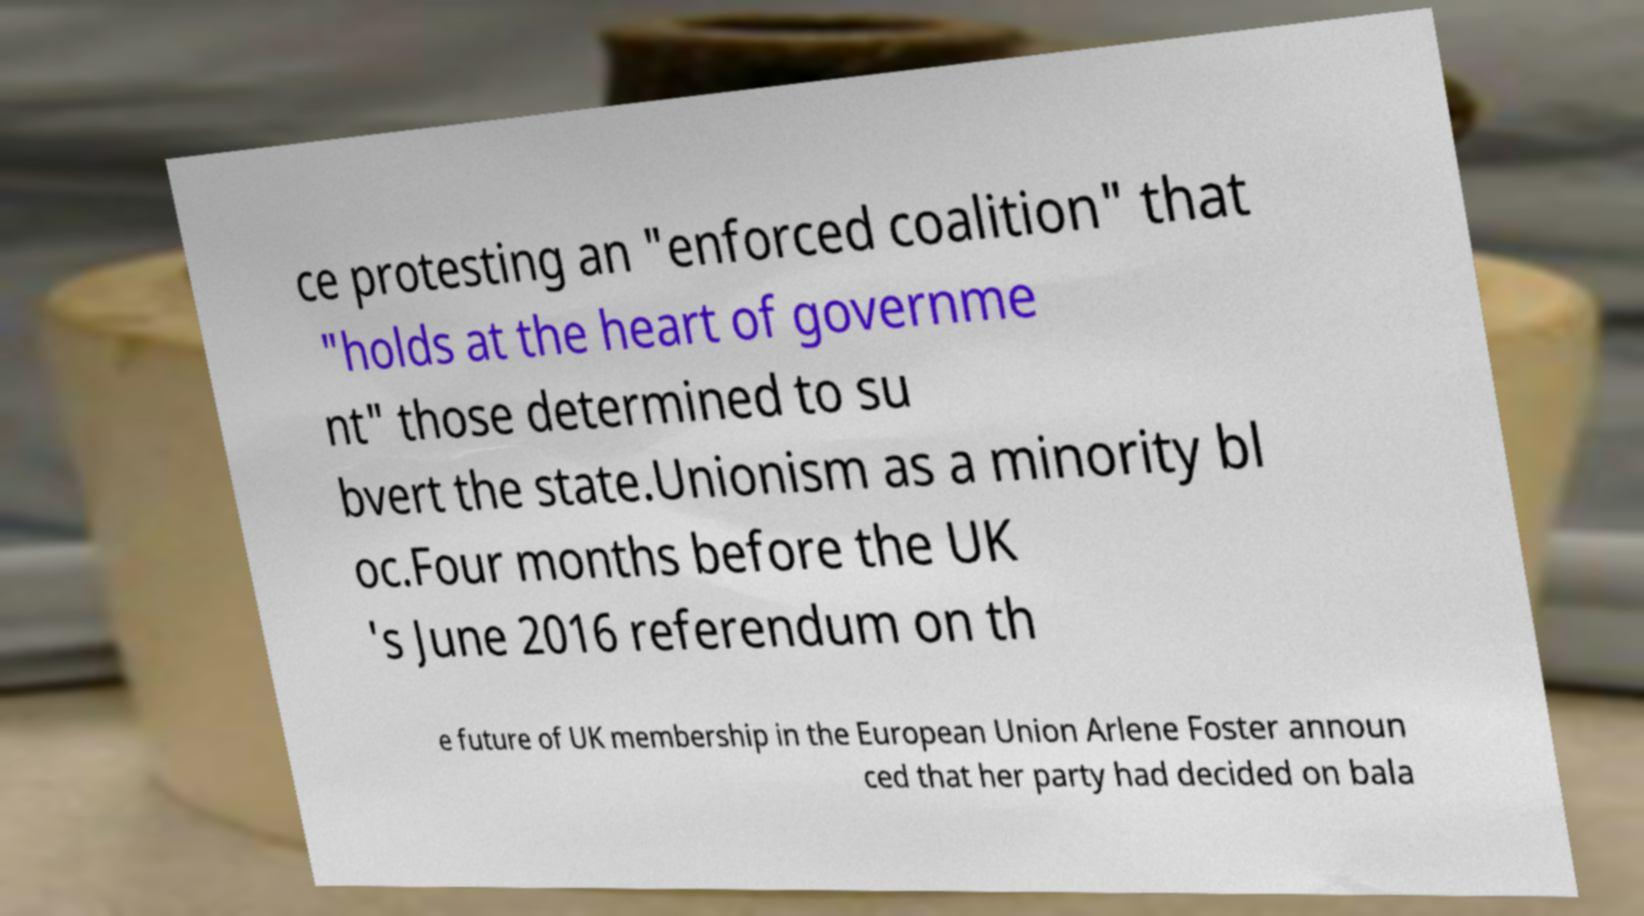Please read and relay the text visible in this image. What does it say? ce protesting an "enforced coalition" that "holds at the heart of governme nt" those determined to su bvert the state.Unionism as a minority bl oc.Four months before the UK 's June 2016 referendum on th e future of UK membership in the European Union Arlene Foster announ ced that her party had decided on bala 